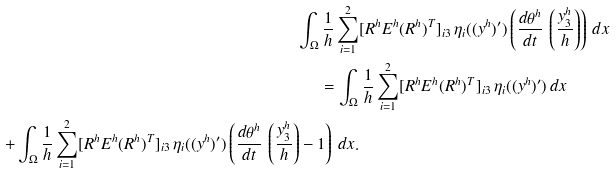<formula> <loc_0><loc_0><loc_500><loc_500>\int _ { \Omega } \frac { 1 } { h } \sum _ { i = 1 } ^ { 2 } & [ R ^ { h } E ^ { h } ( R ^ { h } ) ^ { T } ] _ { i 3 } \, \eta _ { i } ( ( y ^ { h } ) ^ { \prime } ) \left ( \frac { d \theta ^ { h } } { d t } \, \left ( \frac { y _ { 3 } ^ { h } } { h } \right ) \right ) \, d x \\ = \int _ { \Omega } & \, \frac { 1 } { h } \sum _ { i = 1 } ^ { 2 } [ R ^ { h } E ^ { h } ( R ^ { h } ) ^ { T } ] _ { i 3 } \, \eta _ { i } ( ( y ^ { h } ) ^ { \prime } ) \, d x \\ + \int _ { \Omega } \frac { 1 } { h } \sum _ { i = 1 } ^ { 2 } [ R ^ { h } E ^ { h } ( R ^ { h } ) ^ { T } ] _ { i 3 } \, \eta _ { i } ( ( y ^ { h } ) ^ { \prime } ) \left ( \frac { d \theta ^ { h } } { d t } \, \left ( \frac { y _ { 3 } ^ { h } } { h } \right ) - 1 \right ) \, d x .</formula> 